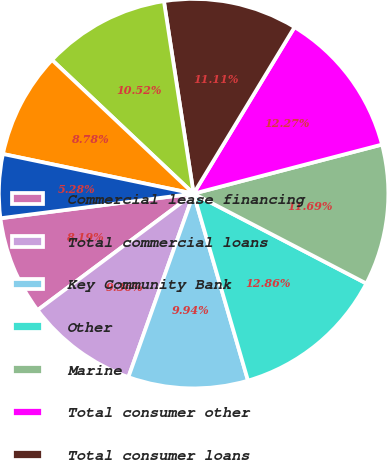Convert chart. <chart><loc_0><loc_0><loc_500><loc_500><pie_chart><fcel>Commercial lease financing<fcel>Total commercial loans<fcel>Key Community Bank<fcel>Other<fcel>Marine<fcel>Total consumer other<fcel>Total consumer loans<fcel>Total loans<fcel>Loans held for sale<fcel>Securities available for sale<nl><fcel>8.19%<fcel>9.36%<fcel>9.94%<fcel>12.86%<fcel>11.69%<fcel>12.27%<fcel>11.11%<fcel>10.52%<fcel>8.78%<fcel>5.28%<nl></chart> 